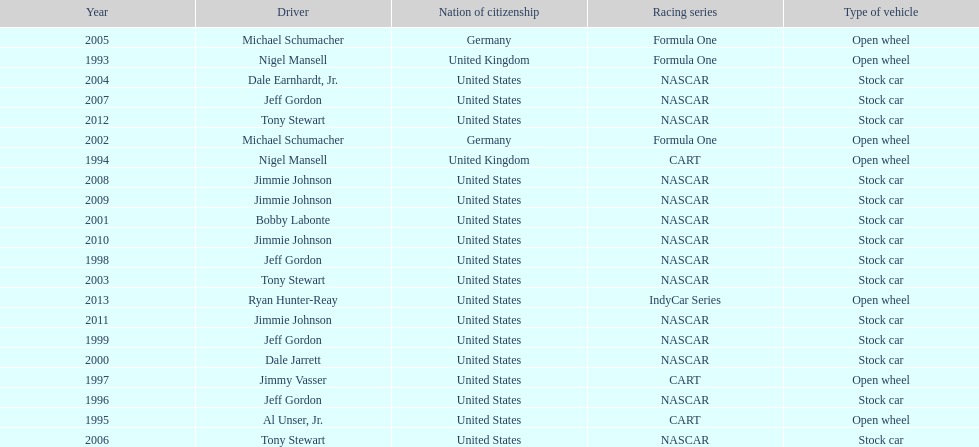Give me the full table as a dictionary. {'header': ['Year', 'Driver', 'Nation of citizenship', 'Racing series', 'Type of vehicle'], 'rows': [['2005', 'Michael Schumacher', 'Germany', 'Formula One', 'Open wheel'], ['1993', 'Nigel Mansell', 'United Kingdom', 'Formula One', 'Open wheel'], ['2004', 'Dale Earnhardt, Jr.', 'United States', 'NASCAR', 'Stock car'], ['2007', 'Jeff Gordon', 'United States', 'NASCAR', 'Stock car'], ['2012', 'Tony Stewart', 'United States', 'NASCAR', 'Stock car'], ['2002', 'Michael Schumacher', 'Germany', 'Formula One', 'Open wheel'], ['1994', 'Nigel Mansell', 'United Kingdom', 'CART', 'Open wheel'], ['2008', 'Jimmie Johnson', 'United States', 'NASCAR', 'Stock car'], ['2009', 'Jimmie Johnson', 'United States', 'NASCAR', 'Stock car'], ['2001', 'Bobby Labonte', 'United States', 'NASCAR', 'Stock car'], ['2010', 'Jimmie Johnson', 'United States', 'NASCAR', 'Stock car'], ['1998', 'Jeff Gordon', 'United States', 'NASCAR', 'Stock car'], ['2003', 'Tony Stewart', 'United States', 'NASCAR', 'Stock car'], ['2013', 'Ryan Hunter-Reay', 'United States', 'IndyCar Series', 'Open wheel'], ['2011', 'Jimmie Johnson', 'United States', 'NASCAR', 'Stock car'], ['1999', 'Jeff Gordon', 'United States', 'NASCAR', 'Stock car'], ['2000', 'Dale Jarrett', 'United States', 'NASCAR', 'Stock car'], ['1997', 'Jimmy Vasser', 'United States', 'CART', 'Open wheel'], ['1996', 'Jeff Gordon', 'United States', 'NASCAR', 'Stock car'], ['1995', 'Al Unser, Jr.', 'United States', 'CART', 'Open wheel'], ['2006', 'Tony Stewart', 'United States', 'NASCAR', 'Stock car']]} Out of these drivers: nigel mansell, al unser, jr., michael schumacher, and jeff gordon, all but one has more than one espy award. who only has one espy award? Al Unser, Jr. 